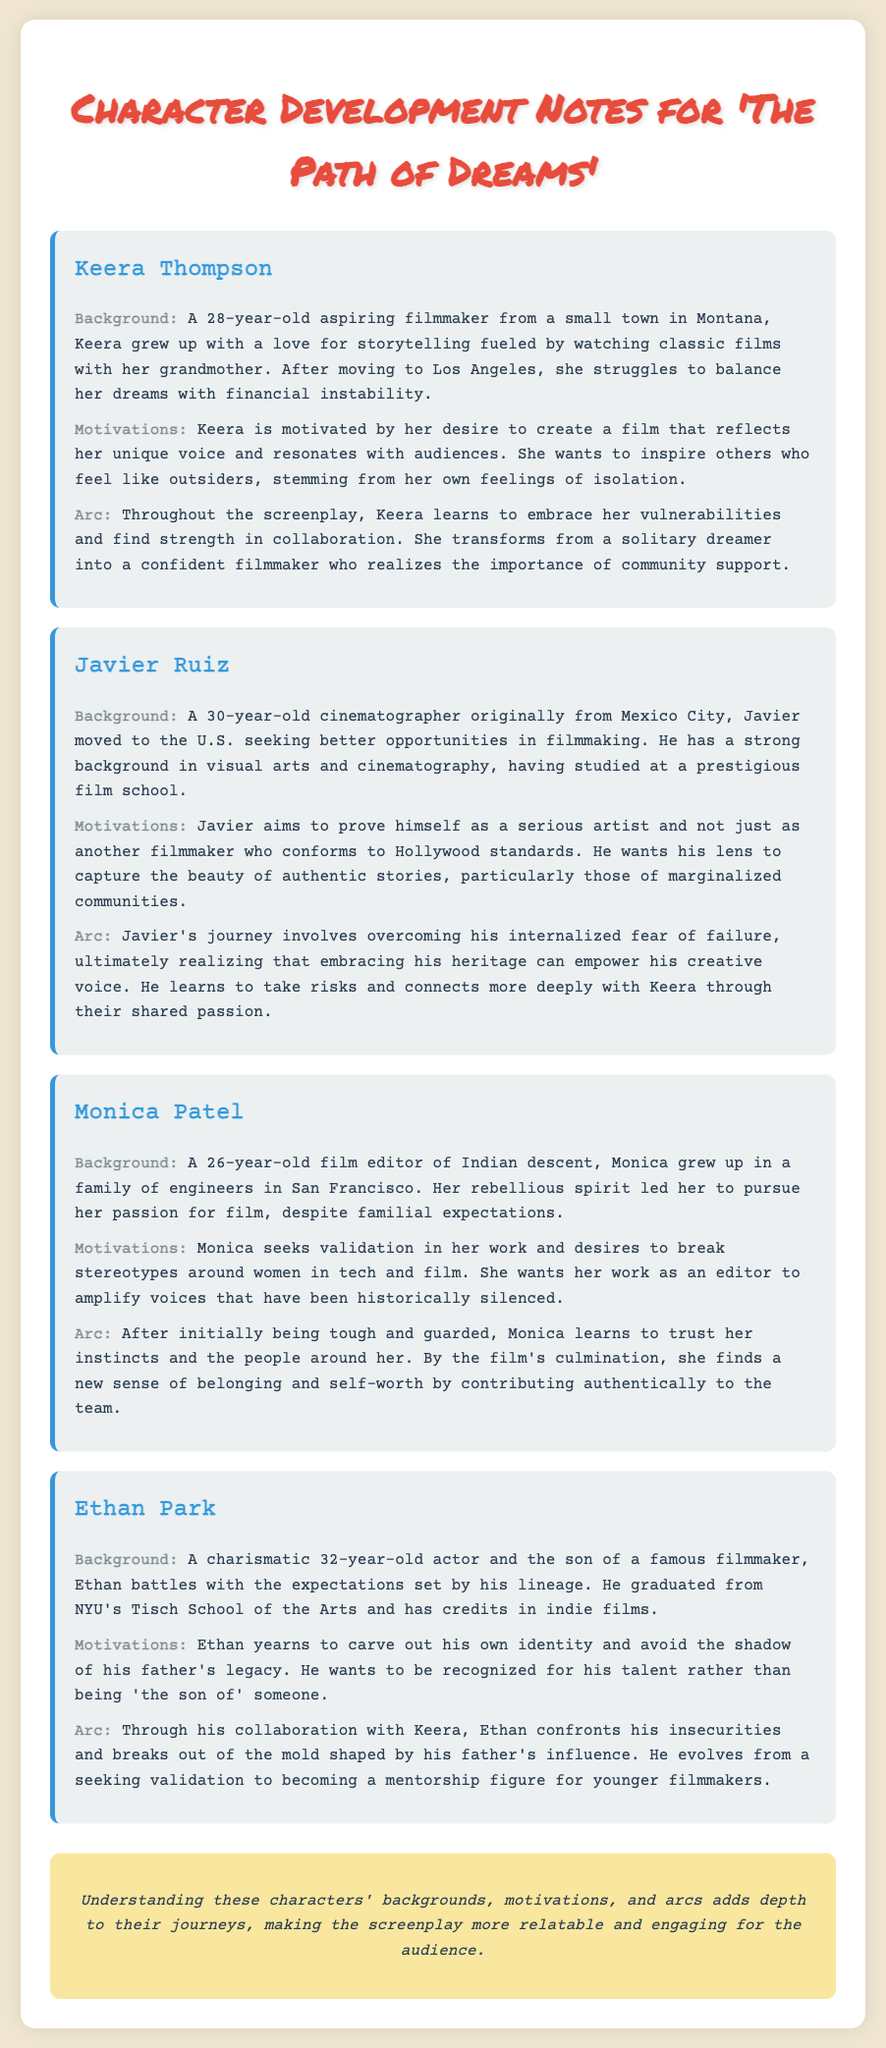What is Keera's age? Keera is explicitly stated to be 28 years old in the document.
Answer: 28 What motivates Javier? The document describes Javier's motivation as wanting to prove himself as a serious artist and capture authentic stories.
Answer: Authentic stories What is Monica's background? Monica is described as a film editor of Indian descent who grew up in a family of engineers in San Francisco.
Answer: Family of engineers in San Francisco What arc does Keera undergo? Keera learns to embrace her vulnerabilities and transforms from a solitary dreamer into a confident filmmaker.
Answer: Confident filmmaker How does Ethan's background influence him? Ethan battles with the expectations set by his father, a famous filmmaker, which shapes his identity crisis.
Answer: Expectations set by his father What does Monica want to break? Monica desires to break stereotypes around women in tech and film, as mentioned in her motivations.
Answer: Stereotypes What transformation does Javier experience? Javier learns to embrace his heritage, empowering his creative voice throughout the screenplay.
Answer: Embrace his heritage What is the main theme of the document? The document focuses on character development, specifically backgrounds, motivations, and arcs of the main characters.
Answer: Character development 